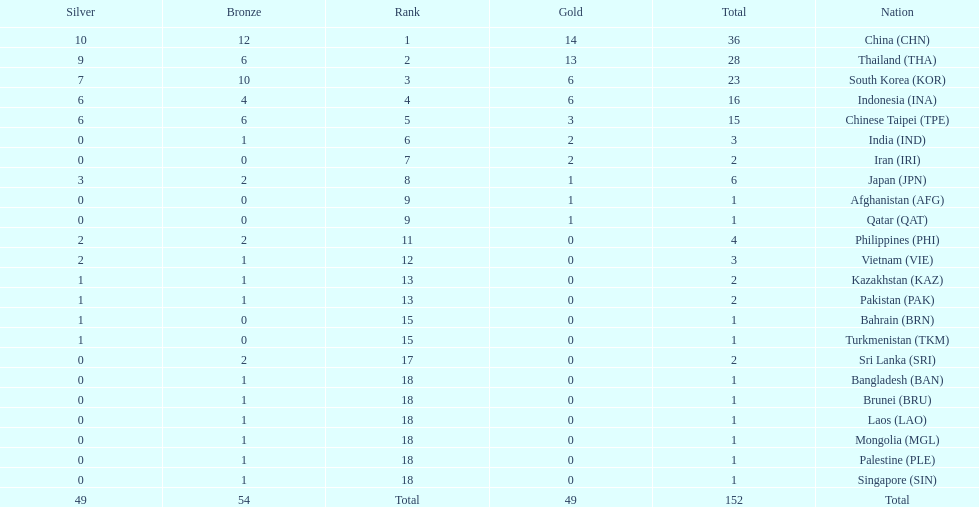What is the total number of nations that participated in the beach games of 2012? 23. 